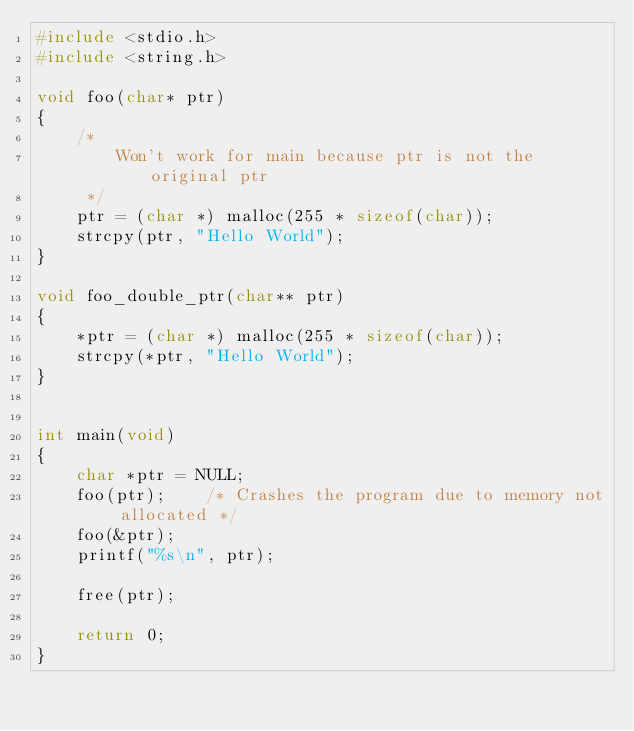Convert code to text. <code><loc_0><loc_0><loc_500><loc_500><_C_>#include <stdio.h>
#include <string.h>

void foo(char* ptr)
{
    /* 
        Won't work for main because ptr is not the original ptr
     */
    ptr = (char *) malloc(255 * sizeof(char)); 
    strcpy(ptr, "Hello World");
}

void foo_double_ptr(char** ptr)
{
    *ptr = (char *) malloc(255 * sizeof(char));
    strcpy(*ptr, "Hello World");
}


int main(void)
{
    char *ptr = NULL;
    foo(ptr);    /* Crashes the program due to memory not allocated */
    foo(&ptr);
    printf("%s\n", ptr);

    free(ptr);

    return 0;
}</code> 